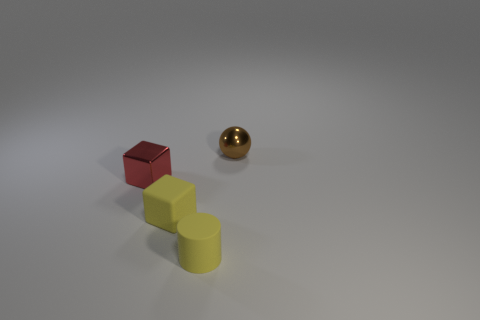Add 1 brown balls. How many objects exist? 5 Subtract all cylinders. How many objects are left? 3 Add 2 rubber blocks. How many rubber blocks are left? 3 Add 4 small green shiny objects. How many small green shiny objects exist? 4 Subtract 0 cyan spheres. How many objects are left? 4 Subtract all metallic balls. Subtract all small shiny cubes. How many objects are left? 2 